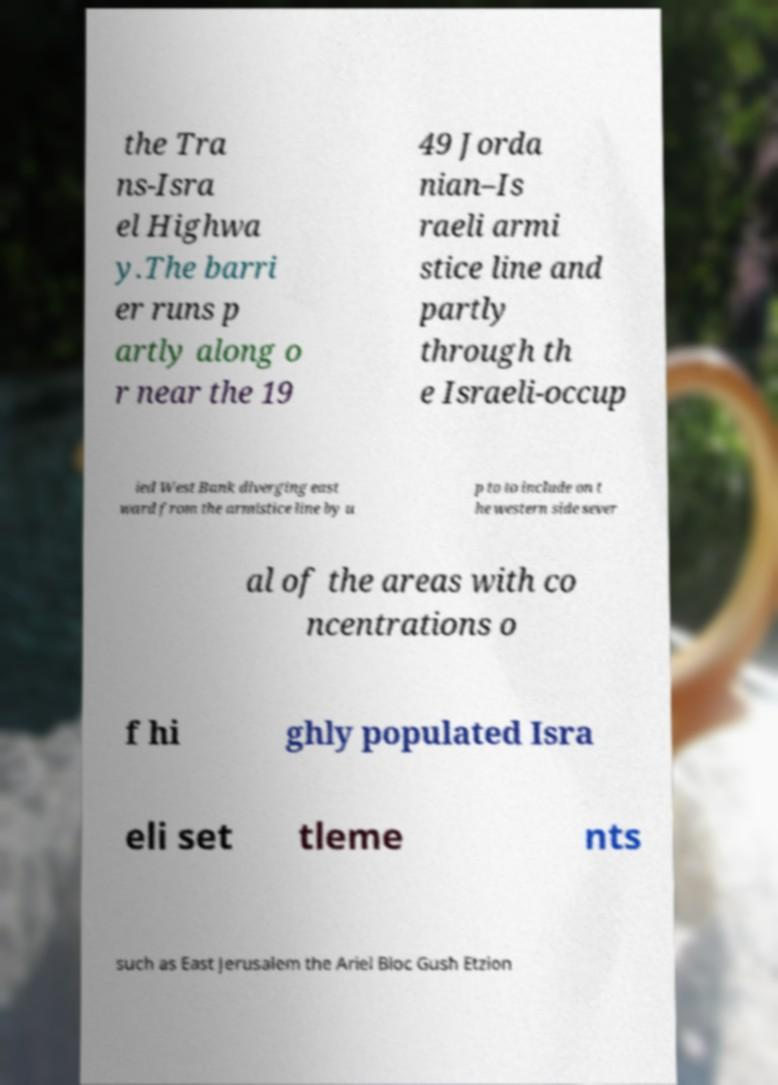Please identify and transcribe the text found in this image. the Tra ns-Isra el Highwa y.The barri er runs p artly along o r near the 19 49 Jorda nian–Is raeli armi stice line and partly through th e Israeli-occup ied West Bank diverging east ward from the armistice line by u p to to include on t he western side sever al of the areas with co ncentrations o f hi ghly populated Isra eli set tleme nts such as East Jerusalem the Ariel Bloc Gush Etzion 